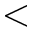Convert formula to latex. <formula><loc_0><loc_0><loc_500><loc_500><</formula> 